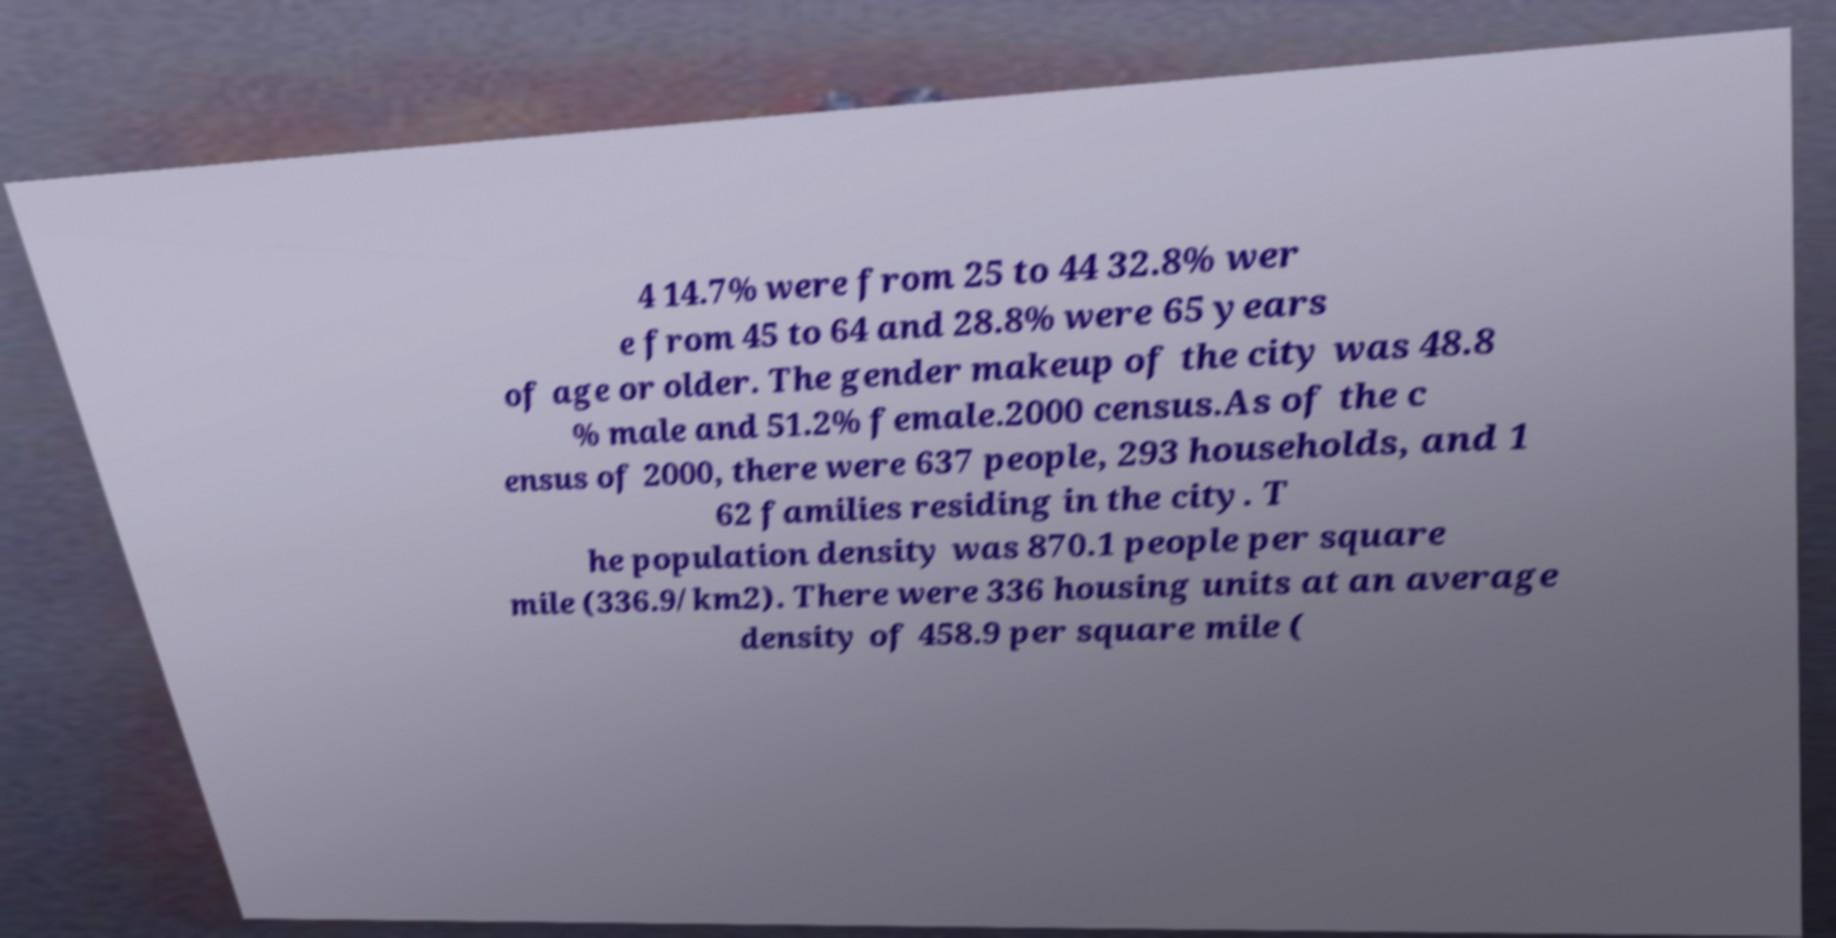Could you assist in decoding the text presented in this image and type it out clearly? 4 14.7% were from 25 to 44 32.8% wer e from 45 to 64 and 28.8% were 65 years of age or older. The gender makeup of the city was 48.8 % male and 51.2% female.2000 census.As of the c ensus of 2000, there were 637 people, 293 households, and 1 62 families residing in the city. T he population density was 870.1 people per square mile (336.9/km2). There were 336 housing units at an average density of 458.9 per square mile ( 